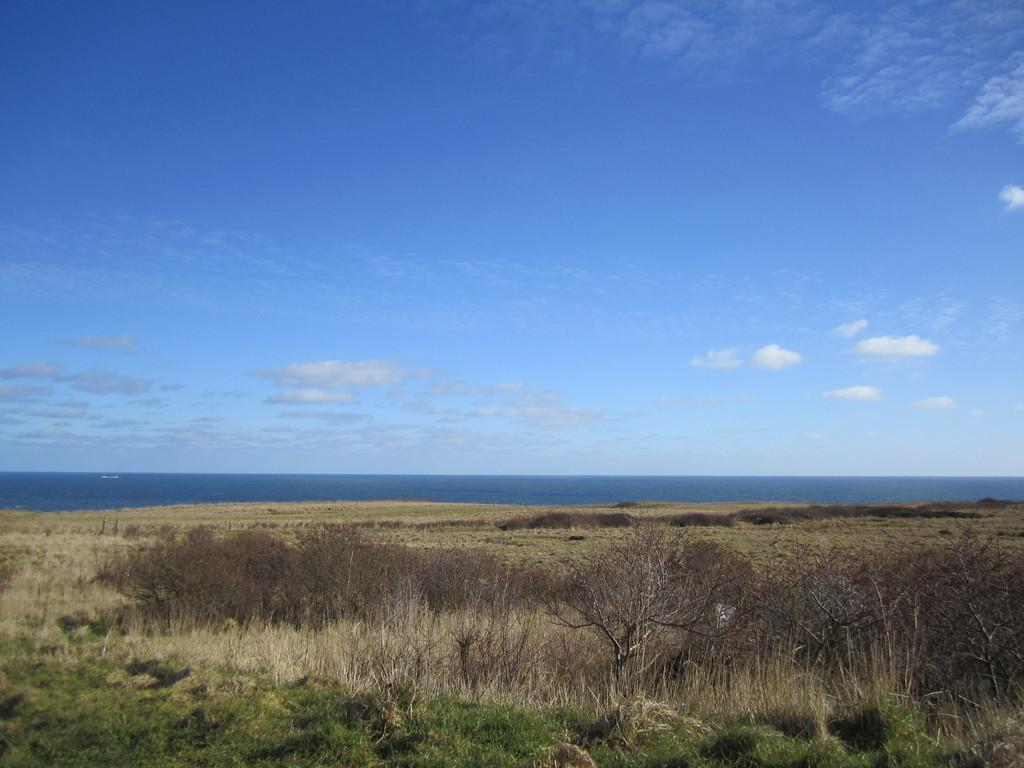What type of vegetation can be seen in the image? There is grass in the image. What is the condition of the trees in the image? The trees in the image are dry. What else can be seen in the image besides vegetation? There is water visible in the image. What is visible in the background of the image? The sky is visible in the background of the image. What can be observed in the sky? There are clouds in the sky. What type of wren can be seen perched on the trees in the image? There are no wrens present in the image; only dry trees and grass can be seen. What type of ring is visible on the water in the image? There is no ring visible on the water in the image. 